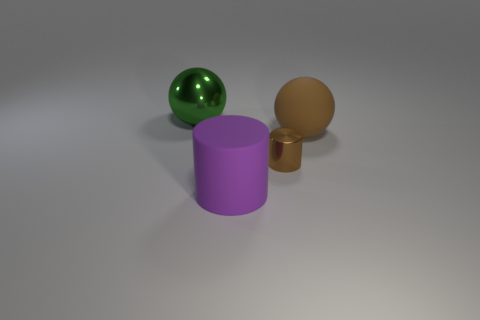What number of objects are either brown cylinders or objects that are in front of the big brown matte sphere?
Your response must be concise. 2. Is there a large matte thing that is to the left of the sphere that is to the right of the big purple object?
Your answer should be compact. Yes. What color is the sphere to the right of the big green shiny thing?
Offer a very short reply. Brown. Is the number of large purple cylinders that are behind the small cylinder the same as the number of small brown metal cylinders?
Provide a short and direct response. No. There is a big thing that is both left of the large brown rubber sphere and behind the purple thing; what shape is it?
Offer a very short reply. Sphere. What is the color of the shiny object that is the same shape as the big brown matte thing?
Provide a short and direct response. Green. Is there any other thing of the same color as the big matte cylinder?
Make the answer very short. No. The brown thing that is in front of the big ball in front of the big thing to the left of the purple cylinder is what shape?
Provide a short and direct response. Cylinder. Does the matte object right of the purple rubber thing have the same size as the shiny object that is left of the tiny shiny thing?
Ensure brevity in your answer.  Yes. What number of brown balls are the same material as the large purple object?
Ensure brevity in your answer.  1. 